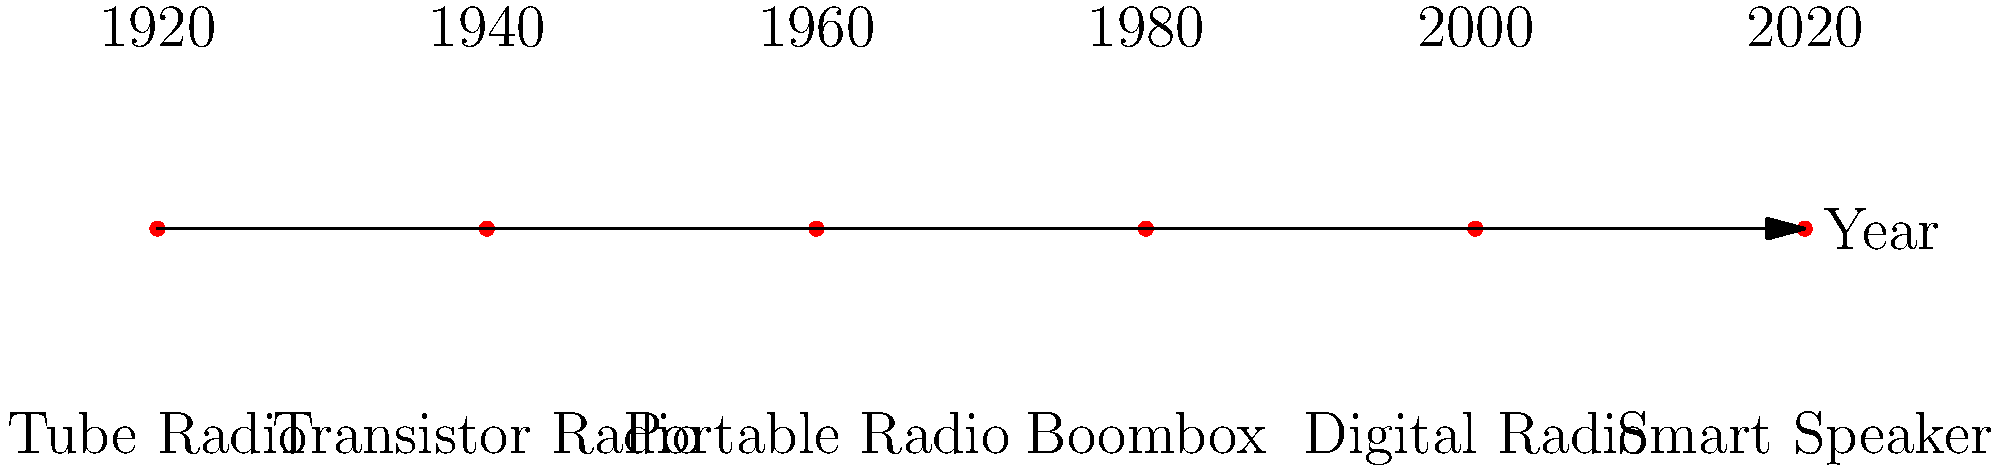Based on the timeline of radio device designs shown above, which era marked the transition from stationary to more portable radio listening experiences? To answer this question, let's analyze the evolution of radio designs through the decades:

1. 1920s: Tube Radio - These were large, stationary devices that required connection to power outlets.

2. 1940s: Transistor Radio - This marked a significant shift in radio technology. Transistors replaced vacuum tubes, allowing for smaller, more portable designs.

3. 1960s: Portable Radio - Building on transistor technology, these radios were designed specifically for portability, often battery-powered and compact.

4. 1980s: Boombox - While larger than portable radios, these devices emphasized mobility and outdoor use, often featuring handles for easy carrying.

5. 2000s: Digital Radio - These incorporated digital technology but maintained portability.

6. 2020s: Smart Speaker - While often stationary, these devices offer wireless connectivity and portability within homes.

The key transition from stationary to portable designs occurred with the introduction of transistor radios in the 1940s. This technology allowed for significantly smaller and more energy-efficient devices, paving the way for truly portable radio experiences in the following decades.
Answer: 1940s (Transistor Radio era) 